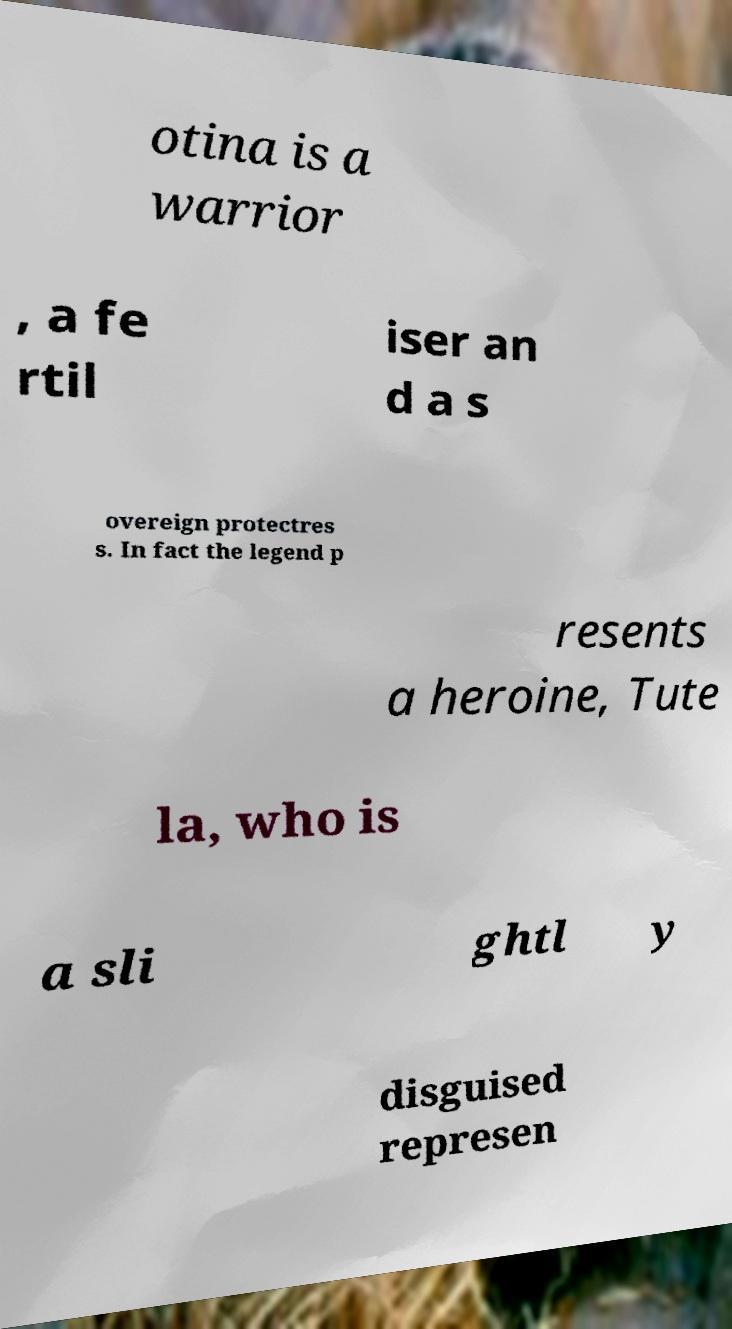Could you assist in decoding the text presented in this image and type it out clearly? otina is a warrior , a fe rtil iser an d a s overeign protectres s. In fact the legend p resents a heroine, Tute la, who is a sli ghtl y disguised represen 